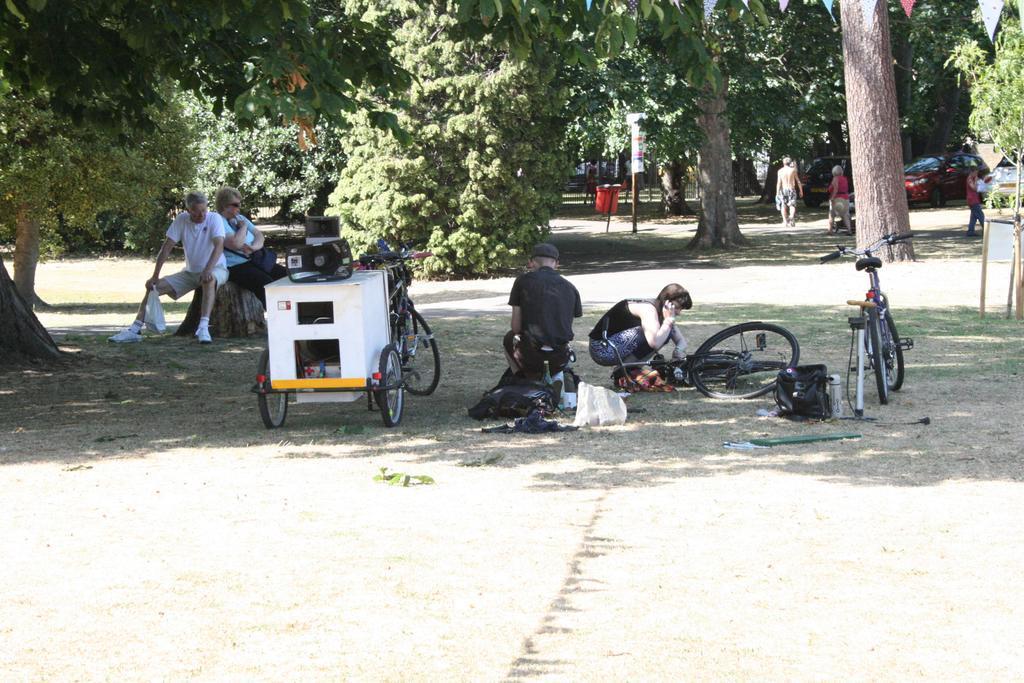Please provide a concise description of this image. In this picture we can see bicycles on the ground, bags, bottle, cart, loud speakers, some people, cars, dustbin, some objects and in the background we can see trees. 